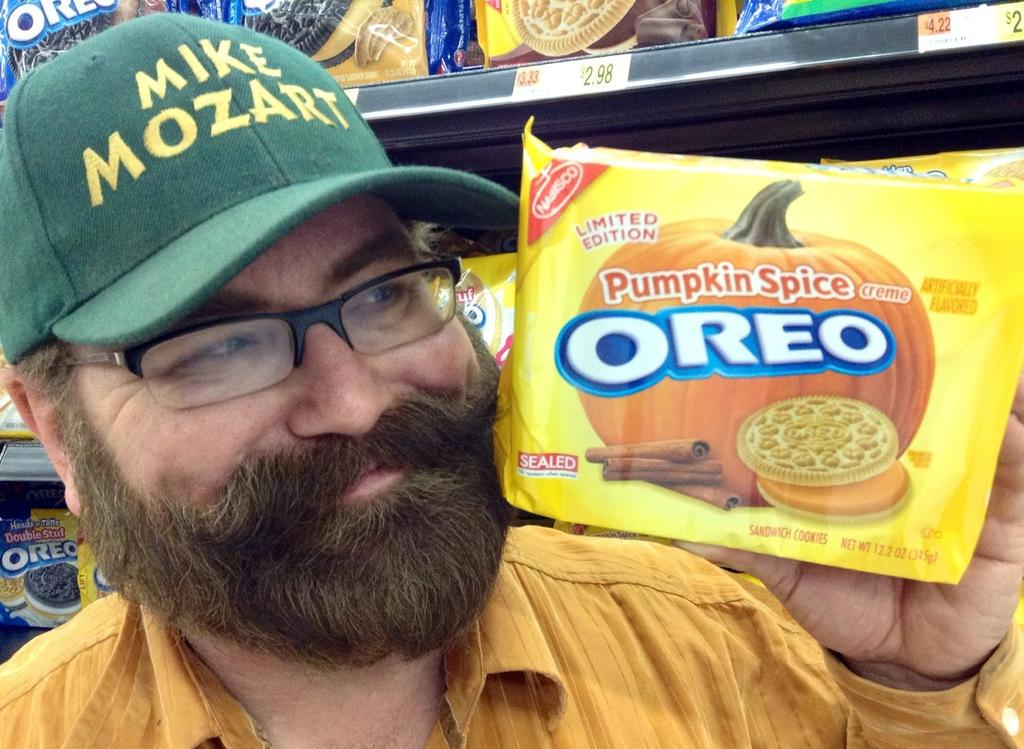Who is present in the image? There is a man in the picture. What is the man wearing on his head? The man is wearing a cap. What is the man holding in the image? The man is holding a biscuit packet. What is the man's facial expression in the image? The man is smiling at someone. What is the chance of a girl appearing in the image? There is no girl present in the image, so it's not possible to determine the chance of her appearing. 